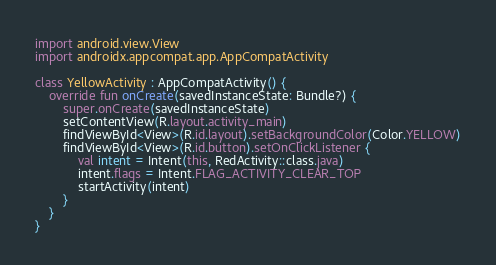<code> <loc_0><loc_0><loc_500><loc_500><_Kotlin_>import android.view.View
import androidx.appcompat.app.AppCompatActivity

class YellowActivity : AppCompatActivity() {
    override fun onCreate(savedInstanceState: Bundle?) {
        super.onCreate(savedInstanceState)
        setContentView(R.layout.activity_main)
        findViewById<View>(R.id.layout).setBackgroundColor(Color.YELLOW)
        findViewById<View>(R.id.button).setOnClickListener {
            val intent = Intent(this, RedActivity::class.java)
            intent.flags = Intent.FLAG_ACTIVITY_CLEAR_TOP
            startActivity(intent)
        }
    }
}</code> 